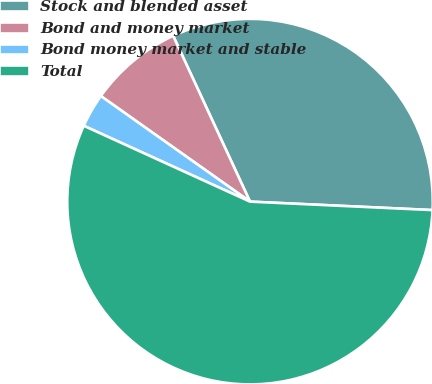<chart> <loc_0><loc_0><loc_500><loc_500><pie_chart><fcel>Stock and blended asset<fcel>Bond and money market<fcel>Bond money market and stable<fcel>Total<nl><fcel>32.65%<fcel>8.29%<fcel>2.99%<fcel>56.08%<nl></chart> 